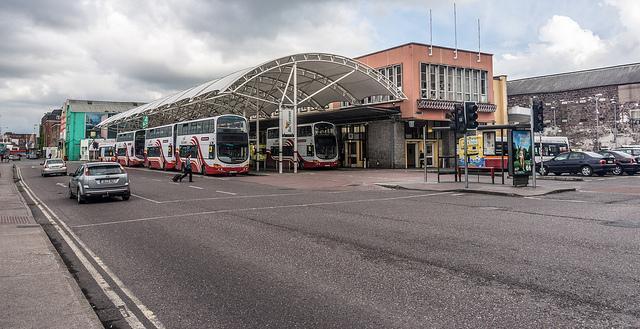What mass transit units sit parked here?
Answer the question by selecting the correct answer among the 4 following choices and explain your choice with a short sentence. The answer should be formatted with the following format: `Answer: choice
Rationale: rationale.`
Options: Busses, trains, cabs, cars. Answer: busses.
Rationale: The vehicles have wheels and cannot travel on tracks. they can carry more passengers than cars. 